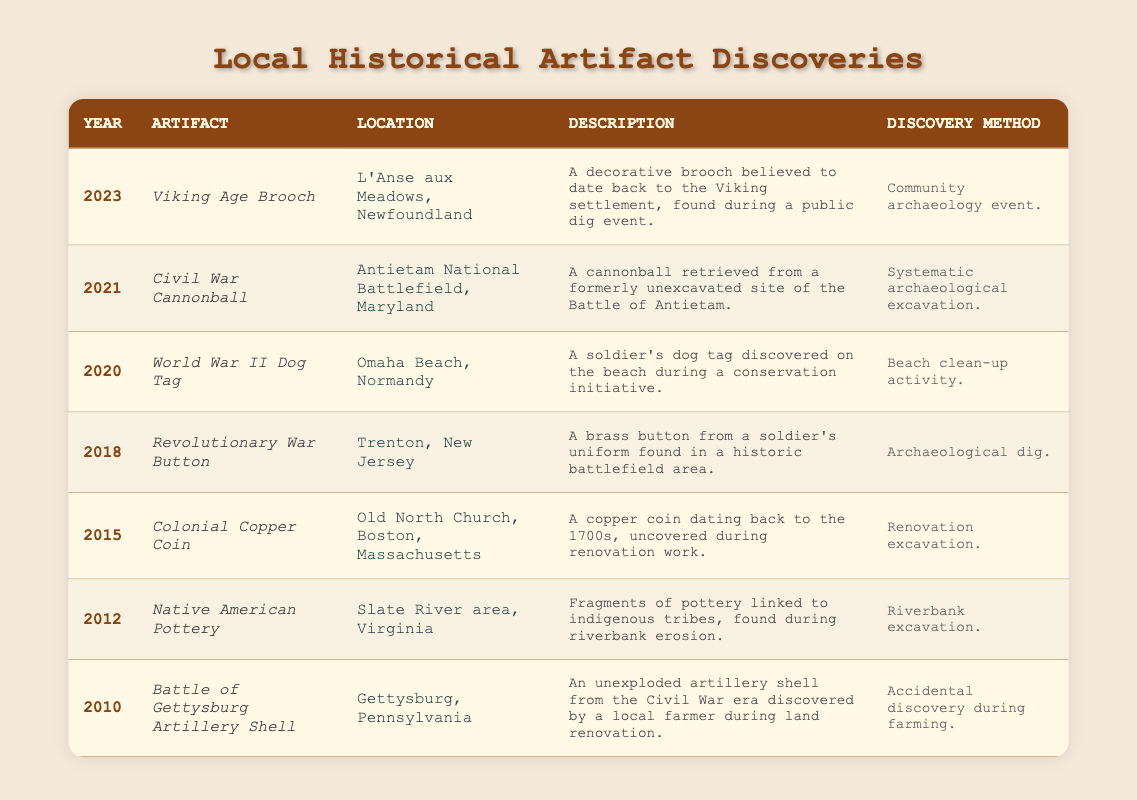What artifact was discovered in 2021? The table indicates that the artifact discovered in 2021 is the Civil War Cannonball, as shown in the corresponding row.
Answer: Civil War Cannonball Which location is associated with the Native American Pottery? The row for Native American Pottery specifies that it was discovered in the Slate River area, Virginia.
Answer: Slate River area, Virginia How many artifacts were discovered between 2010 and 2015? In the years from 2010 to 2015, six artifacts were listed: the Battle of Gettysburg Artillery Shell, Native American Pottery, Colonial Copper Coin, Revolutionary War Button, World War II Dog Tag, and Civil War Cannonball. Counting these yields a total of six items.
Answer: 6 True or False: The Battle of Gettysburg Artillery Shell was discovered during an archaeological dig. According to the table, the discovery method for the Battle of Gettysburg Artillery Shell was an "Accidental discovery during farming," which is not an archaeological dig. Therefore, the statement is false.
Answer: False Which discovery method was used for the Viking Age Brooch? The table shows that the Viking Age Brooch was found during a "Community archaeology event," which is listed under the discovery method column for that artifact.
Answer: Community archaeology event What is the difference in years between the discoveries of the World War II Dog Tag and the Revolutionary War Button? The World War II Dog Tag was discovered in 2020, and the Revolutionary War Button was found in 2018. The difference in years is 2020 - 2018 = 2 years.
Answer: 2 years How many artifacts were discovered in a conservation initiative? Upon reviewing the table, it indicates that only the World War II Dog Tag was discovered during a beach clean-up activity, categorized as a conservation initiative. Hence, there is only one such artifact.
Answer: 1 Which artifact was discovered in the most recent year, and what was its discovery method? The most recent year listed is 2023, and the artifact from that year is the Viking Age Brooch, which was found during a "Community archaeology event."
Answer: Viking Age Brooch, Community archaeology event 